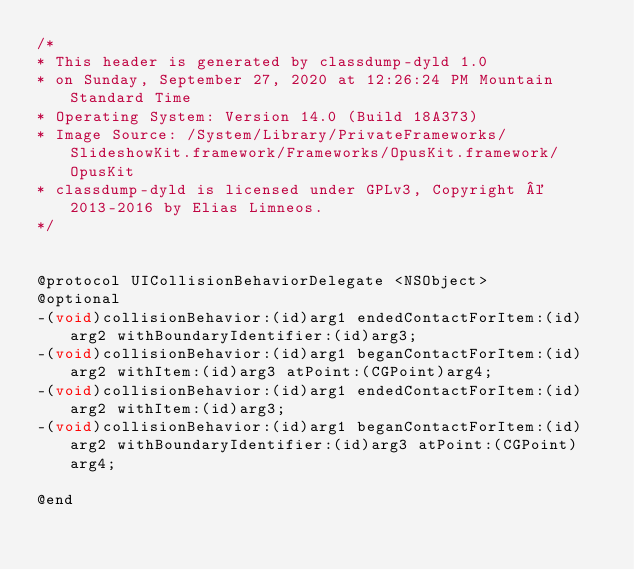<code> <loc_0><loc_0><loc_500><loc_500><_C_>/*
* This header is generated by classdump-dyld 1.0
* on Sunday, September 27, 2020 at 12:26:24 PM Mountain Standard Time
* Operating System: Version 14.0 (Build 18A373)
* Image Source: /System/Library/PrivateFrameworks/SlideshowKit.framework/Frameworks/OpusKit.framework/OpusKit
* classdump-dyld is licensed under GPLv3, Copyright © 2013-2016 by Elias Limneos.
*/


@protocol UICollisionBehaviorDelegate <NSObject>
@optional
-(void)collisionBehavior:(id)arg1 endedContactForItem:(id)arg2 withBoundaryIdentifier:(id)arg3;
-(void)collisionBehavior:(id)arg1 beganContactForItem:(id)arg2 withItem:(id)arg3 atPoint:(CGPoint)arg4;
-(void)collisionBehavior:(id)arg1 endedContactForItem:(id)arg2 withItem:(id)arg3;
-(void)collisionBehavior:(id)arg1 beganContactForItem:(id)arg2 withBoundaryIdentifier:(id)arg3 atPoint:(CGPoint)arg4;

@end

</code> 